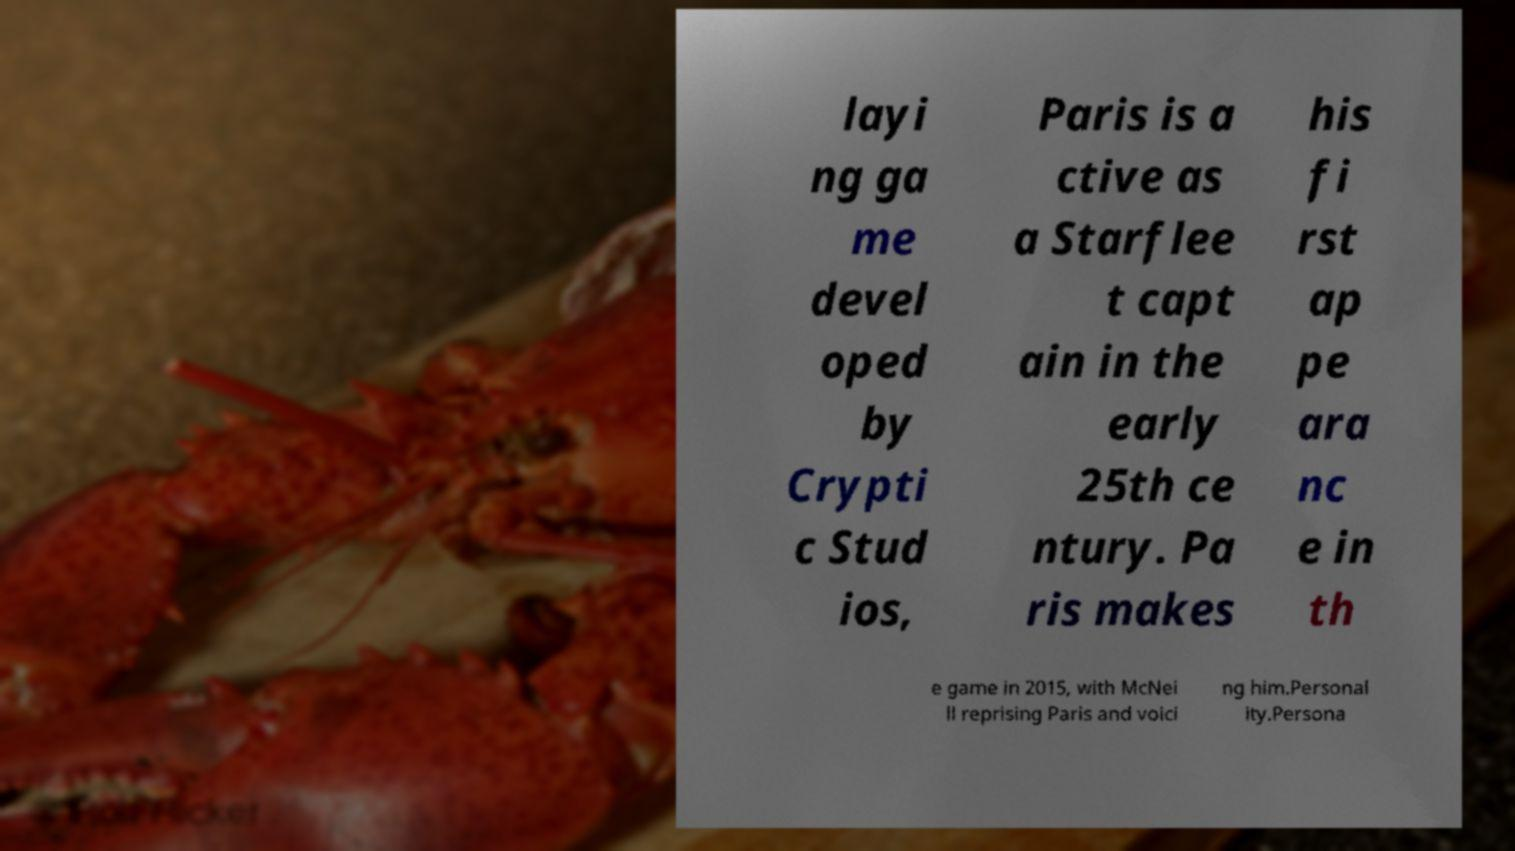I need the written content from this picture converted into text. Can you do that? layi ng ga me devel oped by Crypti c Stud ios, Paris is a ctive as a Starflee t capt ain in the early 25th ce ntury. Pa ris makes his fi rst ap pe ara nc e in th e game in 2015, with McNei ll reprising Paris and voici ng him.Personal ity.Persona 